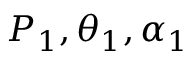<formula> <loc_0><loc_0><loc_500><loc_500>P _ { 1 } , \theta _ { 1 } , \alpha _ { 1 }</formula> 